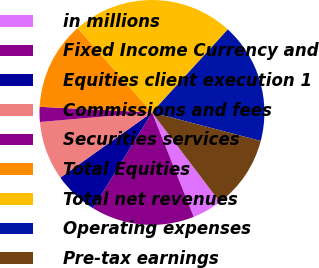Convert chart to OTSL. <chart><loc_0><loc_0><loc_500><loc_500><pie_chart><fcel>in millions<fcel>Fixed Income Currency and<fcel>Equities client execution 1<fcel>Commissions and fees<fcel>Securities services<fcel>Total Equities<fcel>Total net revenues<fcel>Operating expenses<fcel>Pre-tax earnings<nl><fcel>4.27%<fcel>14.83%<fcel>6.38%<fcel>8.49%<fcel>2.15%<fcel>12.71%<fcel>23.28%<fcel>17.29%<fcel>10.6%<nl></chart> 